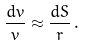<formula> <loc_0><loc_0><loc_500><loc_500>\frac { d v } { v } \approx \frac { d S } { r } \, .</formula> 